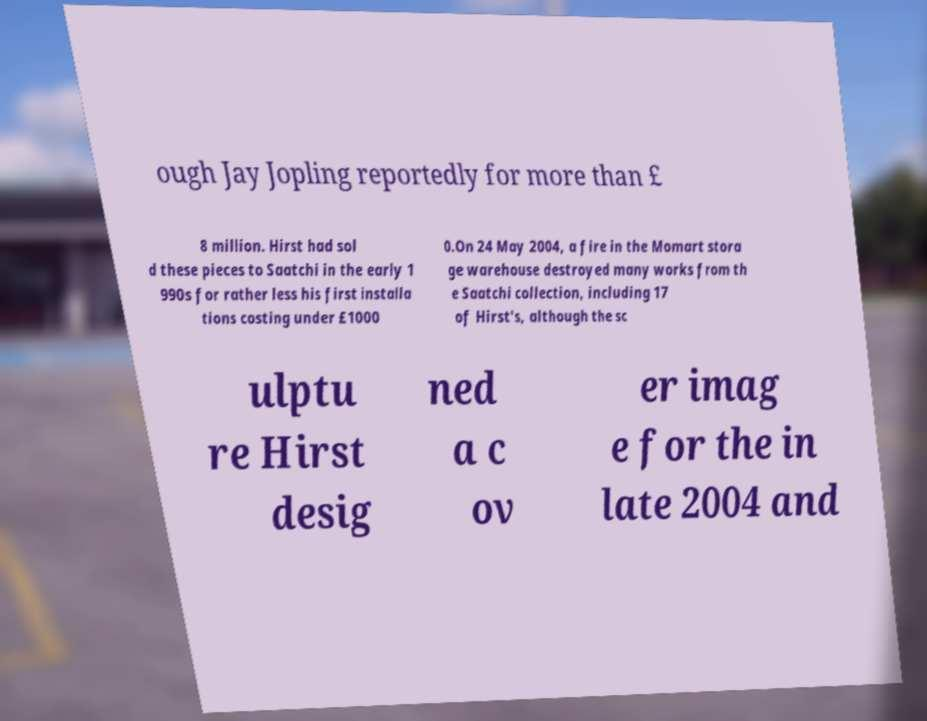Can you accurately transcribe the text from the provided image for me? ough Jay Jopling reportedly for more than £ 8 million. Hirst had sol d these pieces to Saatchi in the early 1 990s for rather less his first installa tions costing under £1000 0.On 24 May 2004, a fire in the Momart stora ge warehouse destroyed many works from th e Saatchi collection, including 17 of Hirst's, although the sc ulptu re Hirst desig ned a c ov er imag e for the in late 2004 and 